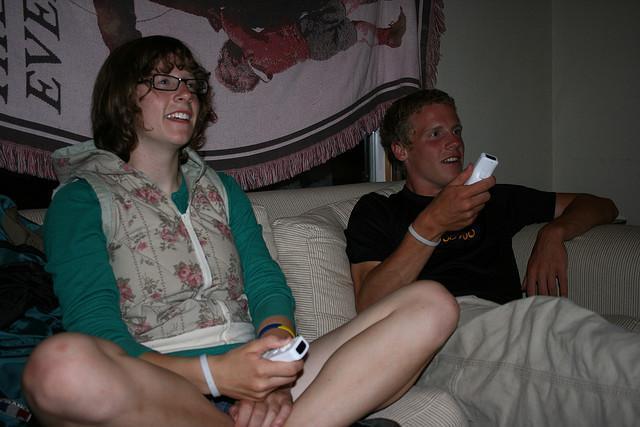How many people are in this picture?
Give a very brief answer. 2. How many people are visible?
Give a very brief answer. 2. 